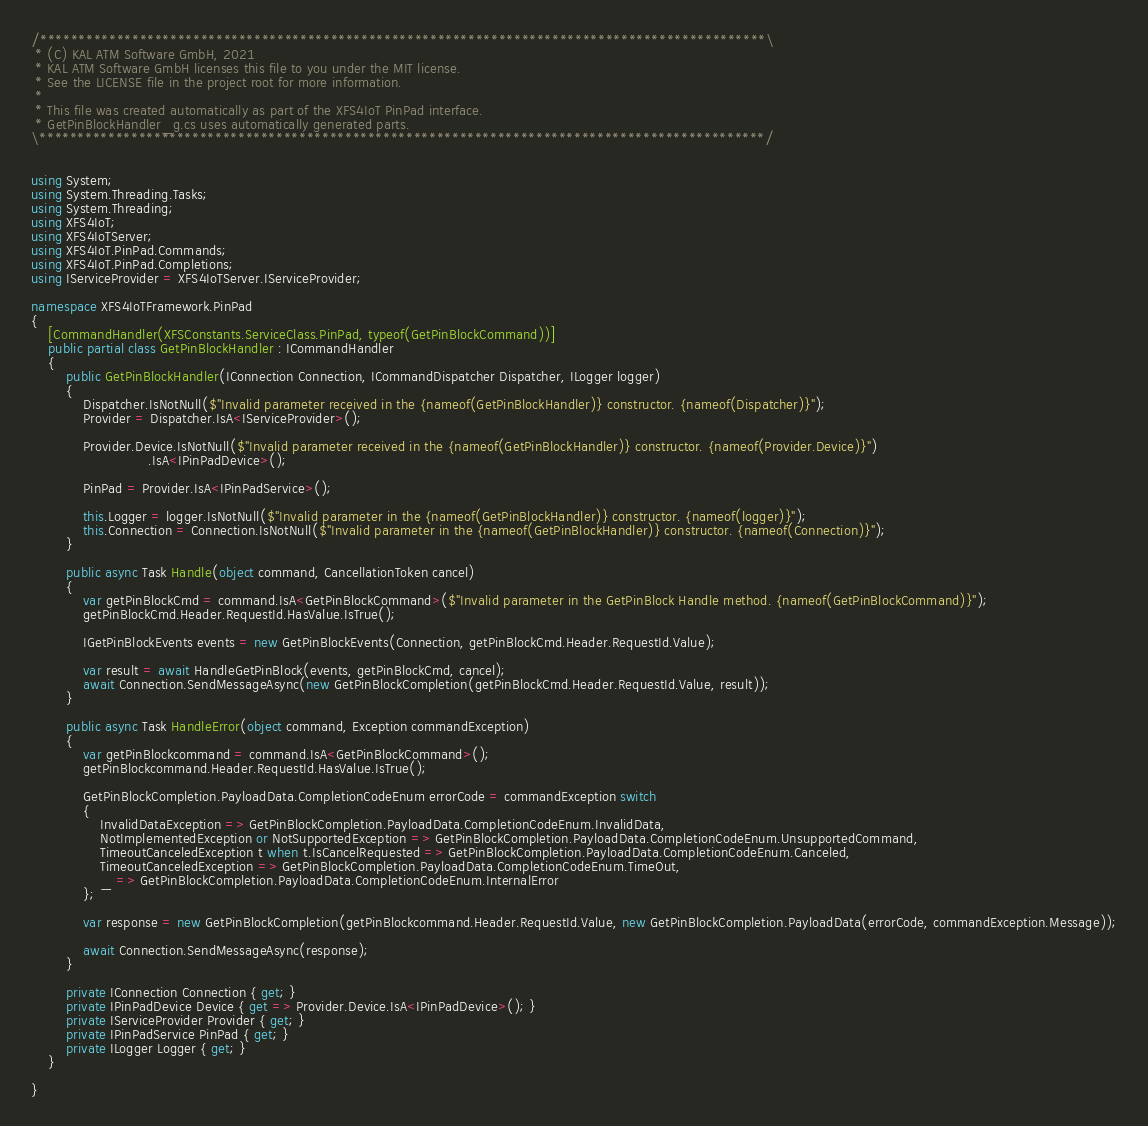<code> <loc_0><loc_0><loc_500><loc_500><_C#_>/***********************************************************************************************\
 * (C) KAL ATM Software GmbH, 2021
 * KAL ATM Software GmbH licenses this file to you under the MIT license.
 * See the LICENSE file in the project root for more information.
 *
 * This file was created automatically as part of the XFS4IoT PinPad interface.
 * GetPinBlockHandler_g.cs uses automatically generated parts.
\***********************************************************************************************/


using System;
using System.Threading.Tasks;
using System.Threading;
using XFS4IoT;
using XFS4IoTServer;
using XFS4IoT.PinPad.Commands;
using XFS4IoT.PinPad.Completions;
using IServiceProvider = XFS4IoTServer.IServiceProvider;

namespace XFS4IoTFramework.PinPad
{
    [CommandHandler(XFSConstants.ServiceClass.PinPad, typeof(GetPinBlockCommand))]
    public partial class GetPinBlockHandler : ICommandHandler
    {
        public GetPinBlockHandler(IConnection Connection, ICommandDispatcher Dispatcher, ILogger logger)
        {
            Dispatcher.IsNotNull($"Invalid parameter received in the {nameof(GetPinBlockHandler)} constructor. {nameof(Dispatcher)}");
            Provider = Dispatcher.IsA<IServiceProvider>();

            Provider.Device.IsNotNull($"Invalid parameter received in the {nameof(GetPinBlockHandler)} constructor. {nameof(Provider.Device)}")
                           .IsA<IPinPadDevice>();

            PinPad = Provider.IsA<IPinPadService>();

            this.Logger = logger.IsNotNull($"Invalid parameter in the {nameof(GetPinBlockHandler)} constructor. {nameof(logger)}");
            this.Connection = Connection.IsNotNull($"Invalid parameter in the {nameof(GetPinBlockHandler)} constructor. {nameof(Connection)}");
        }

        public async Task Handle(object command, CancellationToken cancel)
        {
            var getPinBlockCmd = command.IsA<GetPinBlockCommand>($"Invalid parameter in the GetPinBlock Handle method. {nameof(GetPinBlockCommand)}");
            getPinBlockCmd.Header.RequestId.HasValue.IsTrue();

            IGetPinBlockEvents events = new GetPinBlockEvents(Connection, getPinBlockCmd.Header.RequestId.Value);

            var result = await HandleGetPinBlock(events, getPinBlockCmd, cancel);
            await Connection.SendMessageAsync(new GetPinBlockCompletion(getPinBlockCmd.Header.RequestId.Value, result));
        }

        public async Task HandleError(object command, Exception commandException)
        {
            var getPinBlockcommand = command.IsA<GetPinBlockCommand>();
            getPinBlockcommand.Header.RequestId.HasValue.IsTrue();

            GetPinBlockCompletion.PayloadData.CompletionCodeEnum errorCode = commandException switch
            {
                InvalidDataException => GetPinBlockCompletion.PayloadData.CompletionCodeEnum.InvalidData,
                NotImplementedException or NotSupportedException => GetPinBlockCompletion.PayloadData.CompletionCodeEnum.UnsupportedCommand,
                TimeoutCanceledException t when t.IsCancelRequested => GetPinBlockCompletion.PayloadData.CompletionCodeEnum.Canceled,
                TimeoutCanceledException => GetPinBlockCompletion.PayloadData.CompletionCodeEnum.TimeOut,
                _ => GetPinBlockCompletion.PayloadData.CompletionCodeEnum.InternalError
            };

            var response = new GetPinBlockCompletion(getPinBlockcommand.Header.RequestId.Value, new GetPinBlockCompletion.PayloadData(errorCode, commandException.Message));

            await Connection.SendMessageAsync(response);
        }

        private IConnection Connection { get; }
        private IPinPadDevice Device { get => Provider.Device.IsA<IPinPadDevice>(); }
        private IServiceProvider Provider { get; }
        private IPinPadService PinPad { get; }
        private ILogger Logger { get; }
    }

}
</code> 